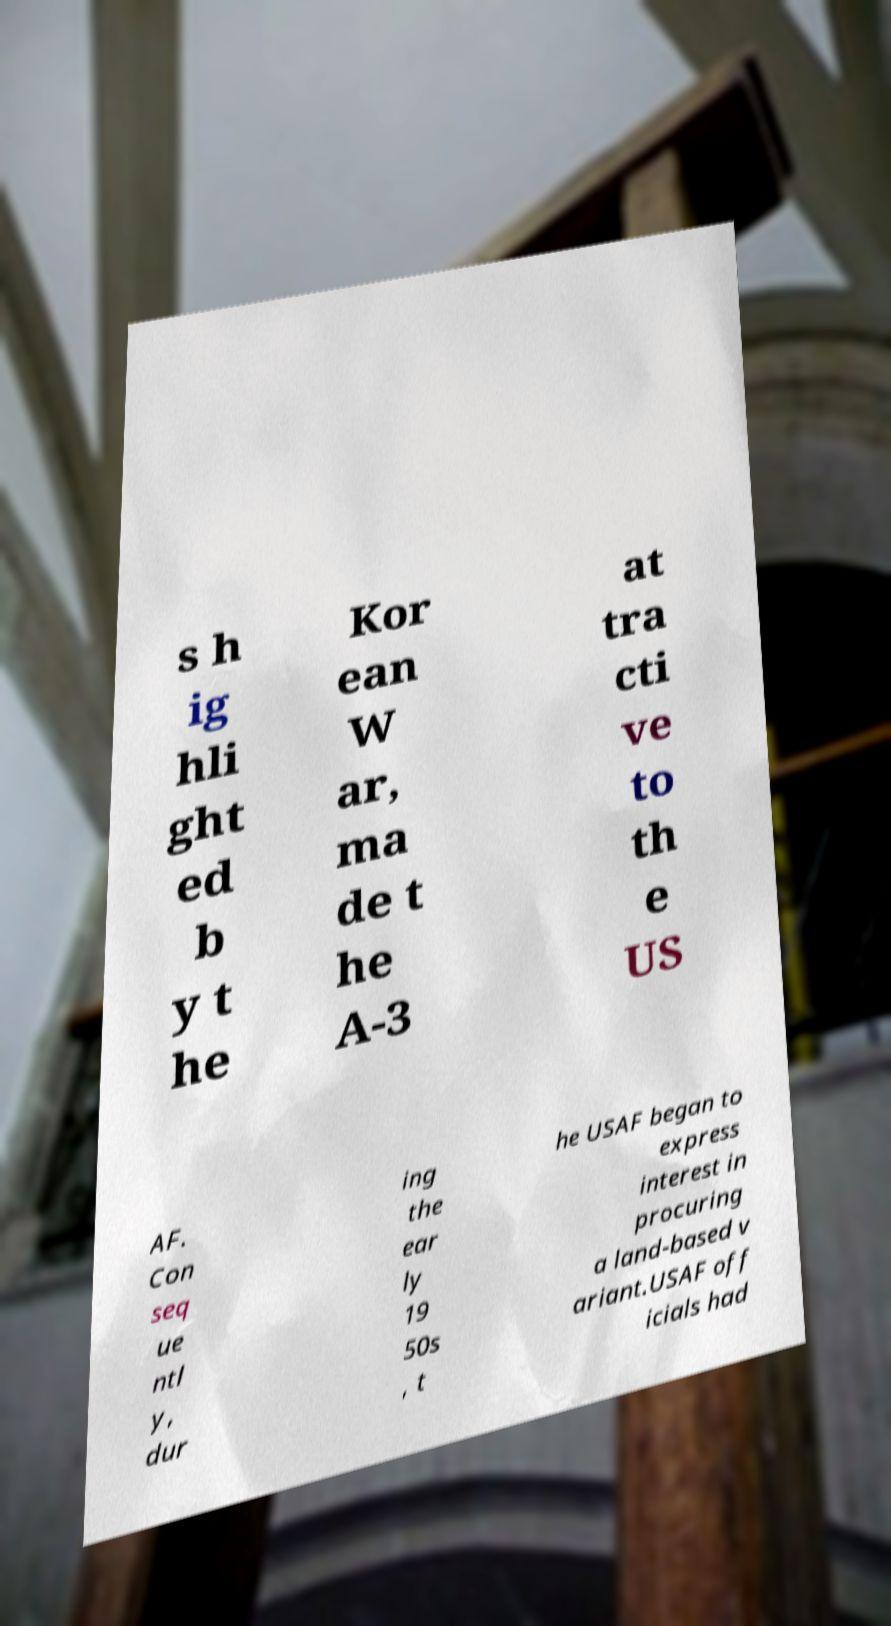There's text embedded in this image that I need extracted. Can you transcribe it verbatim? s h ig hli ght ed b y t he Kor ean W ar, ma de t he A-3 at tra cti ve to th e US AF. Con seq ue ntl y, dur ing the ear ly 19 50s , t he USAF began to express interest in procuring a land-based v ariant.USAF off icials had 